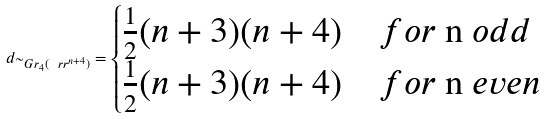Convert formula to latex. <formula><loc_0><loc_0><loc_500><loc_500>d _ { \widetilde { \ } G r _ { 4 } ( \ r r ^ { n + 4 } ) } = \begin{cases} \frac { 1 } { 2 } ( n + 3 ) ( n + 4 ) & f o r $ n $ o d d \\ \frac { 1 } { 2 } ( n + 3 ) ( n + 4 ) & f o r $ n $ e v e n \end{cases}</formula> 